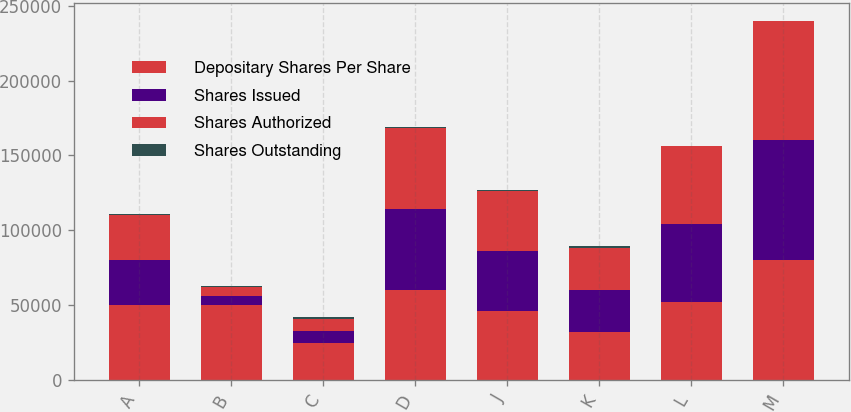<chart> <loc_0><loc_0><loc_500><loc_500><stacked_bar_chart><ecel><fcel>A<fcel>B<fcel>C<fcel>D<fcel>J<fcel>K<fcel>L<fcel>M<nl><fcel>Depositary Shares Per Share<fcel>50000<fcel>50000<fcel>25000<fcel>60000<fcel>46000<fcel>32200<fcel>52000<fcel>80000<nl><fcel>Shares Issued<fcel>30000<fcel>6000<fcel>8000<fcel>54000<fcel>40000<fcel>28000<fcel>52000<fcel>80000<nl><fcel>Shares Authorized<fcel>29999<fcel>6000<fcel>8000<fcel>53999<fcel>40000<fcel>28000<fcel>52000<fcel>80000<nl><fcel>Shares Outstanding<fcel>1000<fcel>1000<fcel>1000<fcel>1000<fcel>1000<fcel>1000<fcel>25<fcel>25<nl></chart> 